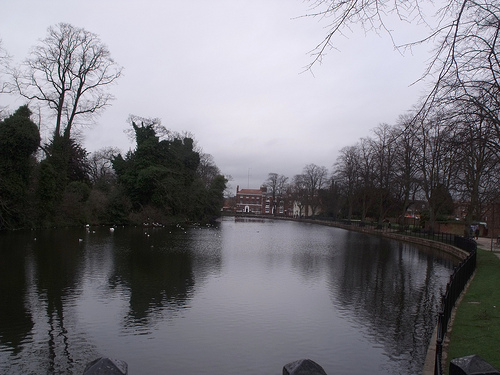<image>
Can you confirm if the house is on the pond? No. The house is not positioned on the pond. They may be near each other, but the house is not supported by or resting on top of the pond. 